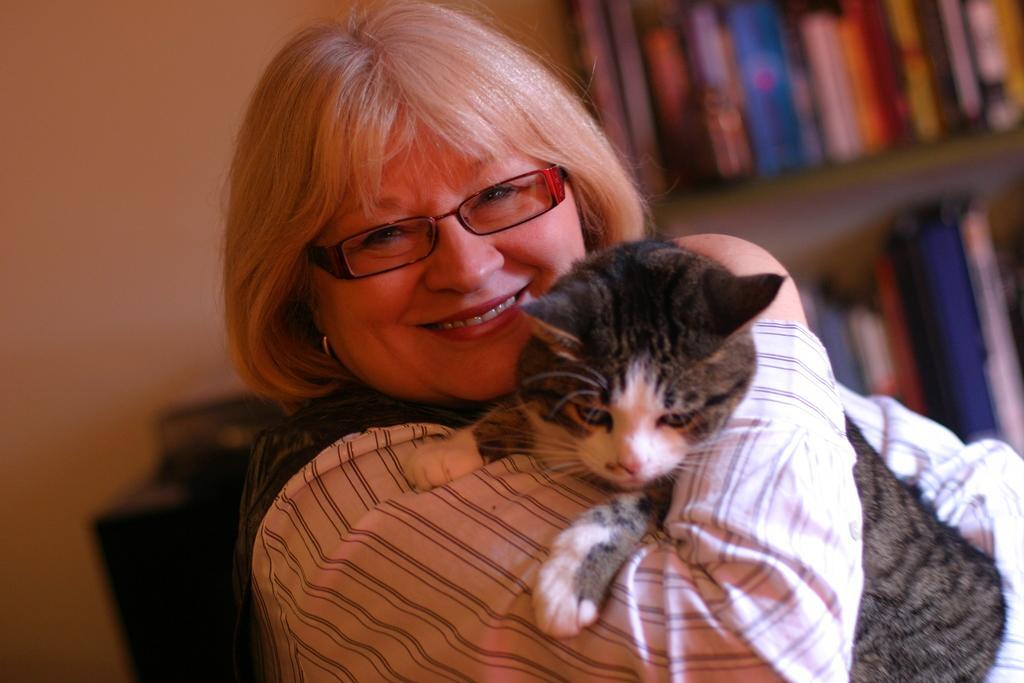In one or two sentences, can you explain what this image depicts? In this image in front there is a person holding the cat. Behind her there is a wooden rack with the books in it. Beside the rock there is a table and on top of the table there is some object. On the backside of the image there is a wall. 